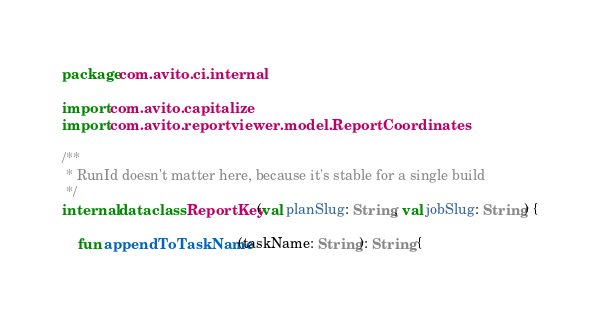<code> <loc_0><loc_0><loc_500><loc_500><_Kotlin_>package com.avito.ci.internal

import com.avito.capitalize
import com.avito.reportviewer.model.ReportCoordinates

/**
 * RunId doesn't matter here, because it's stable for a single build
 */
internal data class ReportKey(val planSlug: String, val jobSlug: String) {

    fun appendToTaskName(taskName: String): String {</code> 